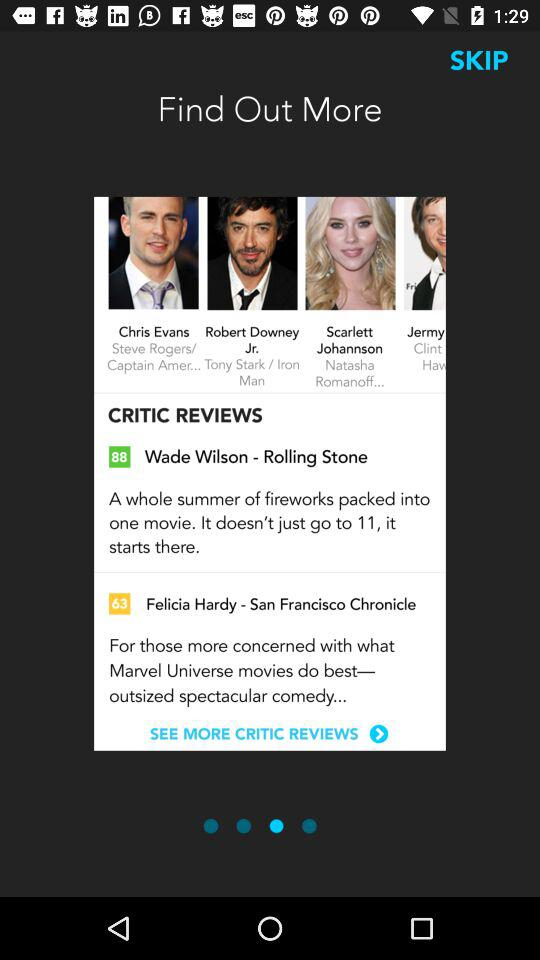How many people are featured in the screenshots?
Answer the question using a single word or phrase. 4 